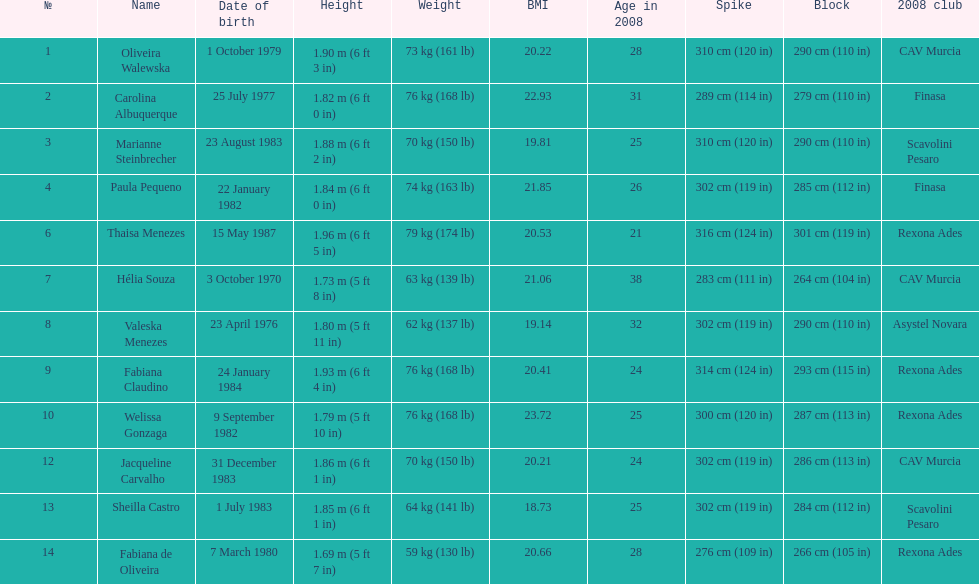Which player is the shortest at only 5 ft 7 in? Fabiana de Oliveira. 